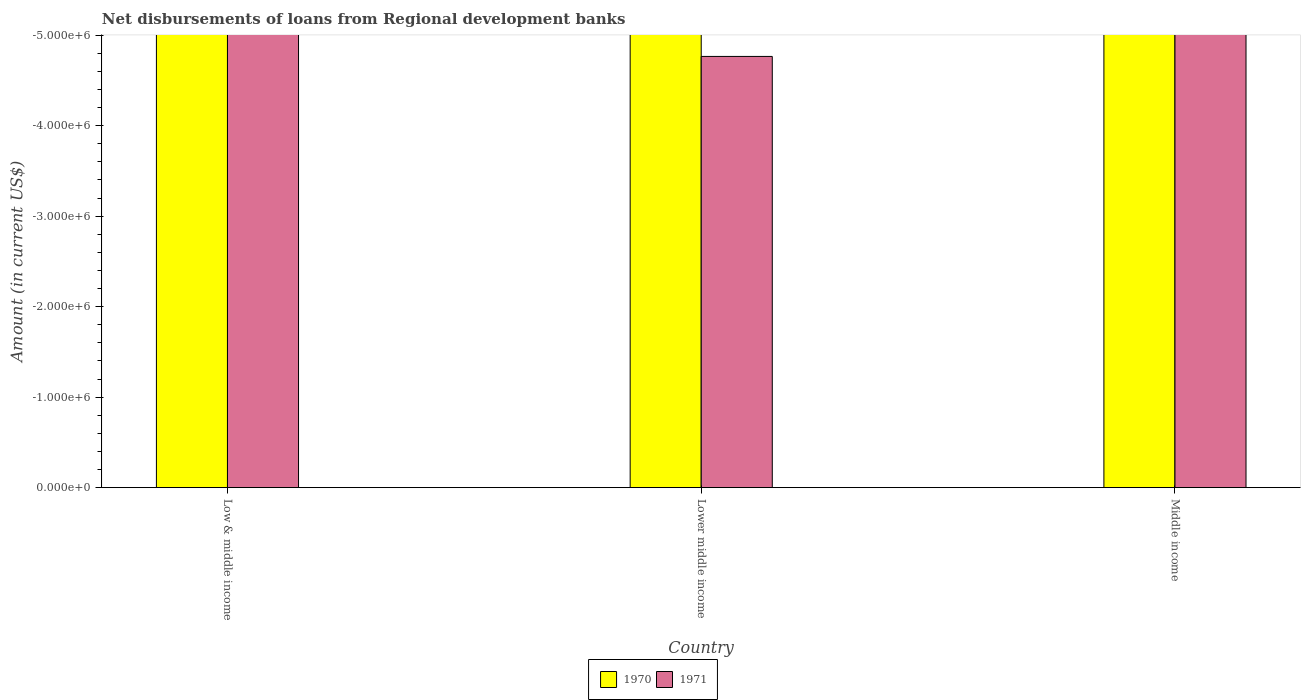How many different coloured bars are there?
Provide a succinct answer. 0. How many bars are there on the 3rd tick from the left?
Offer a terse response. 0. How many bars are there on the 3rd tick from the right?
Make the answer very short. 0. What is the amount of disbursements of loans from regional development banks in 1970 in Low & middle income?
Make the answer very short. 0. Across all countries, what is the minimum amount of disbursements of loans from regional development banks in 1971?
Your answer should be very brief. 0. What is the difference between the amount of disbursements of loans from regional development banks in 1971 in Middle income and the amount of disbursements of loans from regional development banks in 1970 in Low & middle income?
Give a very brief answer. 0. In how many countries, is the amount of disbursements of loans from regional development banks in 1970 greater than -1800000 US$?
Ensure brevity in your answer.  0. In how many countries, is the amount of disbursements of loans from regional development banks in 1971 greater than the average amount of disbursements of loans from regional development banks in 1971 taken over all countries?
Keep it short and to the point. 0. How many bars are there?
Offer a terse response. 0. How many countries are there in the graph?
Ensure brevity in your answer.  3. What is the difference between two consecutive major ticks on the Y-axis?
Keep it short and to the point. 1.00e+06. Are the values on the major ticks of Y-axis written in scientific E-notation?
Ensure brevity in your answer.  Yes. Does the graph contain grids?
Your response must be concise. No. Where does the legend appear in the graph?
Your answer should be compact. Bottom center. How many legend labels are there?
Offer a very short reply. 2. How are the legend labels stacked?
Make the answer very short. Horizontal. What is the title of the graph?
Offer a very short reply. Net disbursements of loans from Regional development banks. Does "2015" appear as one of the legend labels in the graph?
Offer a terse response. No. What is the Amount (in current US$) of 1970 in Low & middle income?
Provide a short and direct response. 0. What is the Amount (in current US$) of 1971 in Low & middle income?
Keep it short and to the point. 0. What is the Amount (in current US$) of 1970 in Lower middle income?
Give a very brief answer. 0. What is the Amount (in current US$) in 1970 in Middle income?
Provide a short and direct response. 0. 